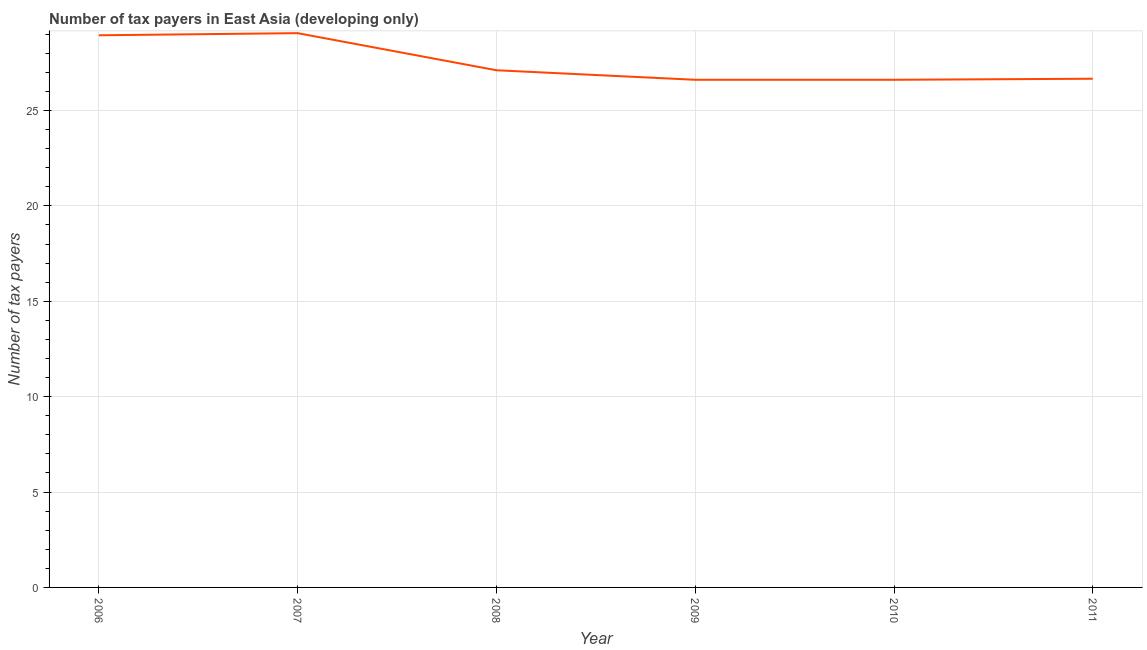What is the number of tax payers in 2010?
Ensure brevity in your answer.  26.61. Across all years, what is the maximum number of tax payers?
Offer a terse response. 29.06. Across all years, what is the minimum number of tax payers?
Ensure brevity in your answer.  26.61. What is the sum of the number of tax payers?
Your answer should be very brief. 165. What is the average number of tax payers per year?
Make the answer very short. 27.5. What is the median number of tax payers?
Ensure brevity in your answer.  26.89. In how many years, is the number of tax payers greater than 23 ?
Keep it short and to the point. 6. What is the ratio of the number of tax payers in 2007 to that in 2010?
Give a very brief answer. 1.09. Is the difference between the number of tax payers in 2006 and 2007 greater than the difference between any two years?
Your response must be concise. No. What is the difference between the highest and the second highest number of tax payers?
Give a very brief answer. 0.11. Is the sum of the number of tax payers in 2007 and 2009 greater than the maximum number of tax payers across all years?
Make the answer very short. Yes. What is the difference between the highest and the lowest number of tax payers?
Give a very brief answer. 2.44. In how many years, is the number of tax payers greater than the average number of tax payers taken over all years?
Your answer should be very brief. 2. Does the number of tax payers monotonically increase over the years?
Keep it short and to the point. No. How many lines are there?
Keep it short and to the point. 1. Are the values on the major ticks of Y-axis written in scientific E-notation?
Offer a terse response. No. What is the title of the graph?
Offer a terse response. Number of tax payers in East Asia (developing only). What is the label or title of the Y-axis?
Make the answer very short. Number of tax payers. What is the Number of tax payers in 2006?
Offer a very short reply. 28.94. What is the Number of tax payers in 2007?
Your answer should be compact. 29.06. What is the Number of tax payers in 2008?
Your answer should be very brief. 27.11. What is the Number of tax payers of 2009?
Offer a very short reply. 26.61. What is the Number of tax payers of 2010?
Ensure brevity in your answer.  26.61. What is the Number of tax payers of 2011?
Your answer should be compact. 26.67. What is the difference between the Number of tax payers in 2006 and 2007?
Your answer should be very brief. -0.11. What is the difference between the Number of tax payers in 2006 and 2008?
Your response must be concise. 1.83. What is the difference between the Number of tax payers in 2006 and 2009?
Offer a terse response. 2.33. What is the difference between the Number of tax payers in 2006 and 2010?
Ensure brevity in your answer.  2.33. What is the difference between the Number of tax payers in 2006 and 2011?
Offer a terse response. 2.28. What is the difference between the Number of tax payers in 2007 and 2008?
Ensure brevity in your answer.  1.94. What is the difference between the Number of tax payers in 2007 and 2009?
Your answer should be compact. 2.44. What is the difference between the Number of tax payers in 2007 and 2010?
Your response must be concise. 2.44. What is the difference between the Number of tax payers in 2007 and 2011?
Your response must be concise. 2.39. What is the difference between the Number of tax payers in 2008 and 2010?
Your response must be concise. 0.5. What is the difference between the Number of tax payers in 2008 and 2011?
Make the answer very short. 0.44. What is the difference between the Number of tax payers in 2009 and 2010?
Keep it short and to the point. 0. What is the difference between the Number of tax payers in 2009 and 2011?
Ensure brevity in your answer.  -0.06. What is the difference between the Number of tax payers in 2010 and 2011?
Offer a very short reply. -0.06. What is the ratio of the Number of tax payers in 2006 to that in 2008?
Offer a terse response. 1.07. What is the ratio of the Number of tax payers in 2006 to that in 2009?
Offer a terse response. 1.09. What is the ratio of the Number of tax payers in 2006 to that in 2010?
Provide a short and direct response. 1.09. What is the ratio of the Number of tax payers in 2006 to that in 2011?
Provide a short and direct response. 1.08. What is the ratio of the Number of tax payers in 2007 to that in 2008?
Provide a short and direct response. 1.07. What is the ratio of the Number of tax payers in 2007 to that in 2009?
Offer a very short reply. 1.09. What is the ratio of the Number of tax payers in 2007 to that in 2010?
Provide a succinct answer. 1.09. What is the ratio of the Number of tax payers in 2007 to that in 2011?
Your answer should be compact. 1.09. What is the ratio of the Number of tax payers in 2008 to that in 2009?
Keep it short and to the point. 1.02. What is the ratio of the Number of tax payers in 2008 to that in 2010?
Your answer should be compact. 1.02. What is the ratio of the Number of tax payers in 2008 to that in 2011?
Offer a terse response. 1.02. 